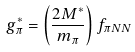<formula> <loc_0><loc_0><loc_500><loc_500>g _ { \pi } ^ { * } = \left ( \frac { 2 M ^ { * } } { m _ { \pi } } \right ) f _ { \pi N N }</formula> 